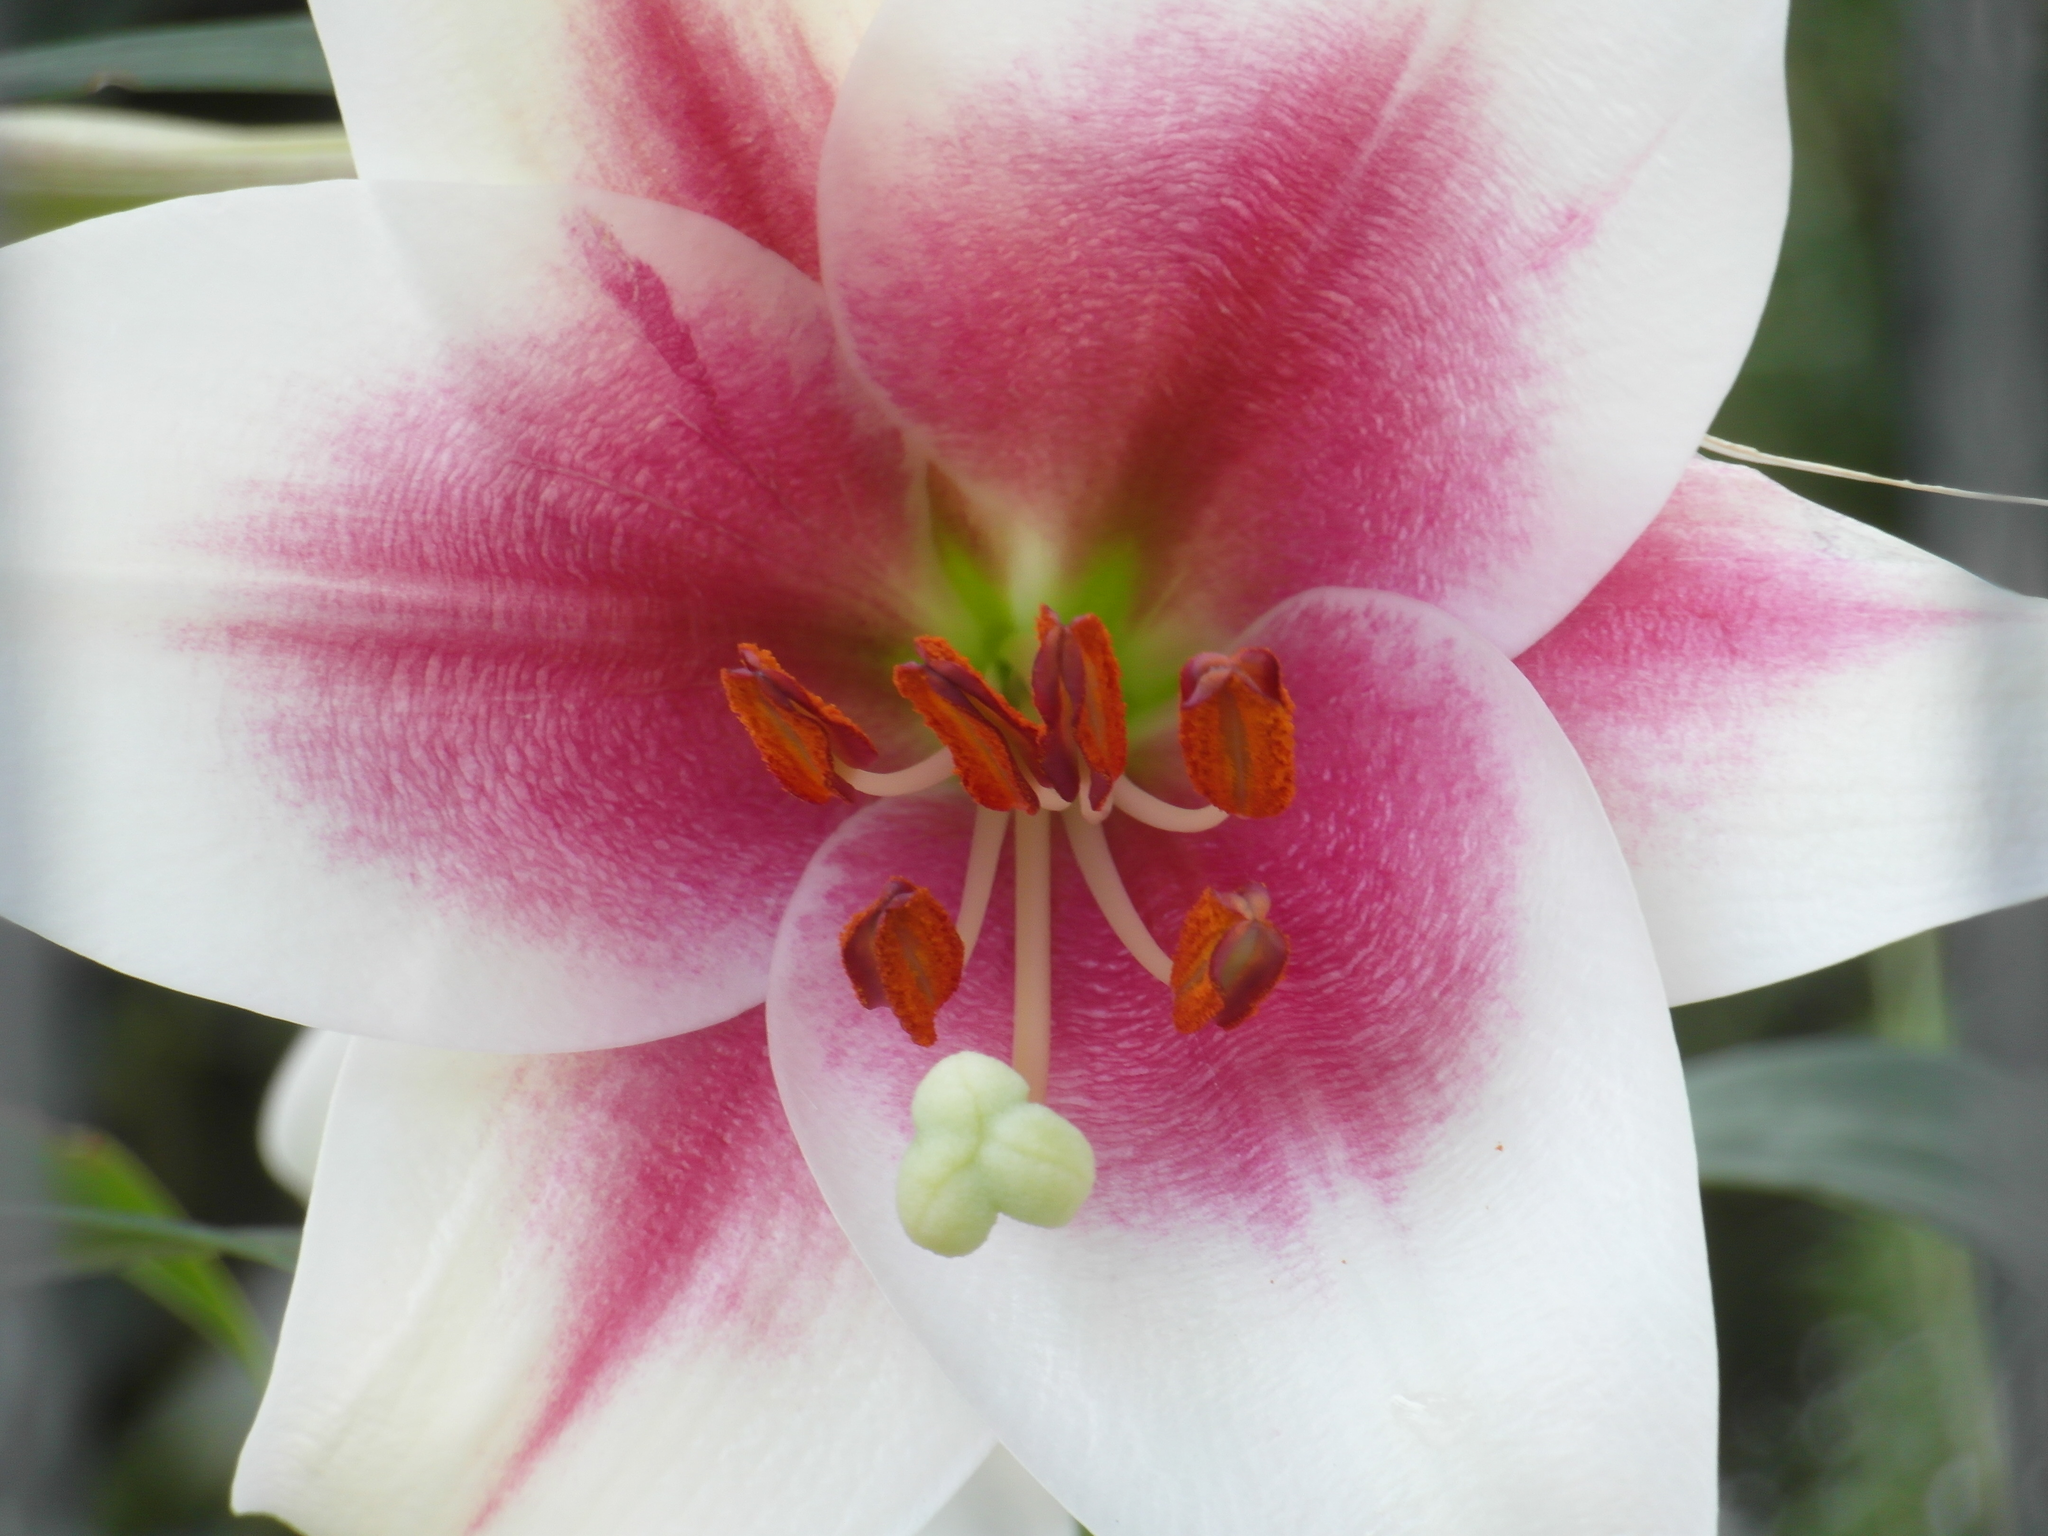In one or two sentences, can you explain what this image depicts? In this image we can see a flower which is white and pink in color, there are some anthers, also we can see some plants, and the background is blurred. 